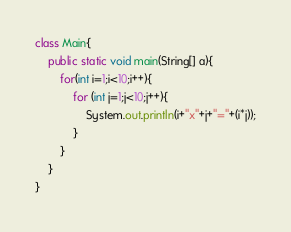Convert code to text. <code><loc_0><loc_0><loc_500><loc_500><_Java_>class Main{
	public static void main(String[] a){
		for(int i=1;i<10;i++){
			for (int j=1;j<10;j++){
				System.out.println(i+"x"+j+"="+(i*j));
			}
		}
	}
}</code> 